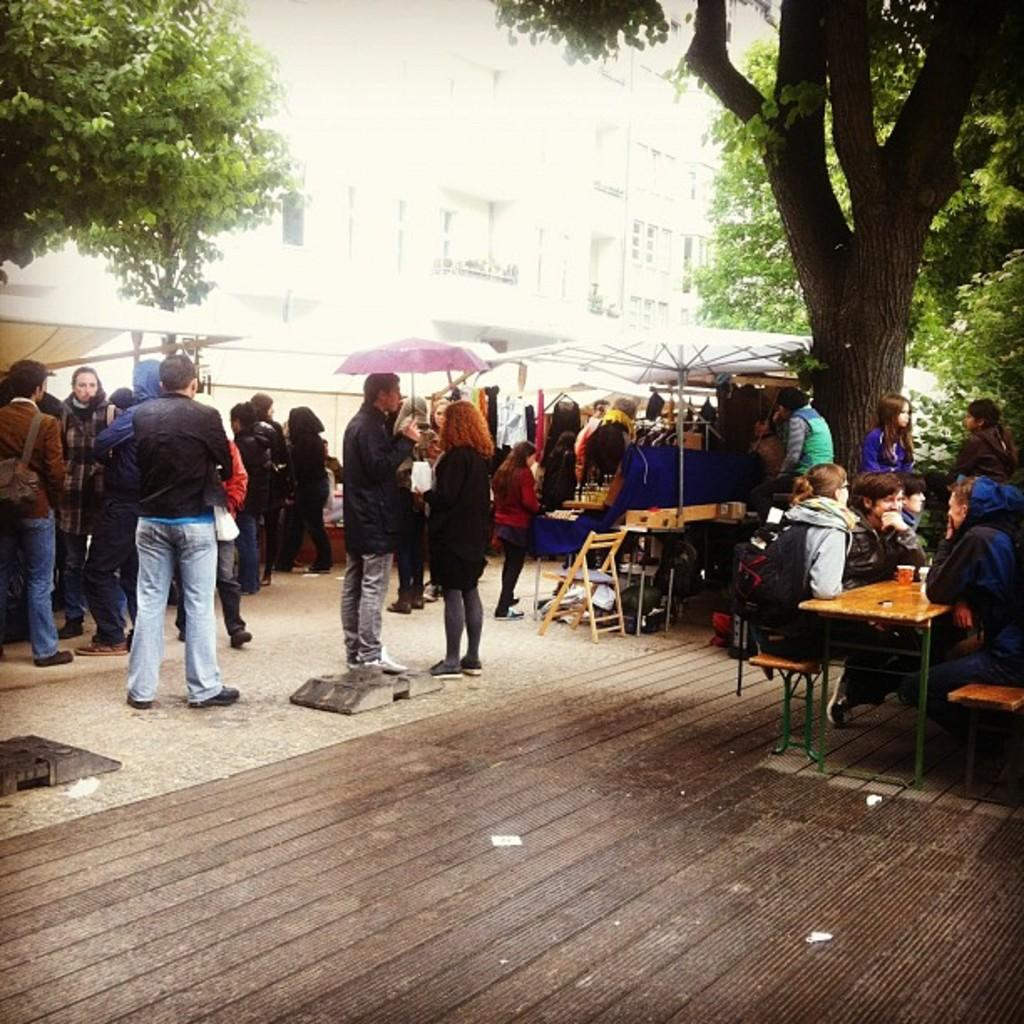What are the people in the image doing? The group of people is standing on the ground. What can be seen in the background of the image? There are trees and buildings visible in the image. What type of neck is the doctor wearing in the image? There is no doctor or neck visible in the image. What kind of music is the band playing in the background? There is no band present in the image, so it is not possible to determine what kind of music they might be playing. 